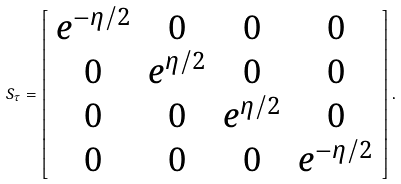<formula> <loc_0><loc_0><loc_500><loc_500>S _ { \tau } = \left [ \begin{array} { c c c c } e ^ { - \eta / 2 } & 0 & 0 & 0 \\ 0 & e ^ { \eta / 2 } & 0 & 0 \\ 0 & 0 & e ^ { \eta / 2 } & 0 \\ 0 & 0 & 0 & e ^ { - \eta / 2 } \\ \end{array} \right ] .</formula> 